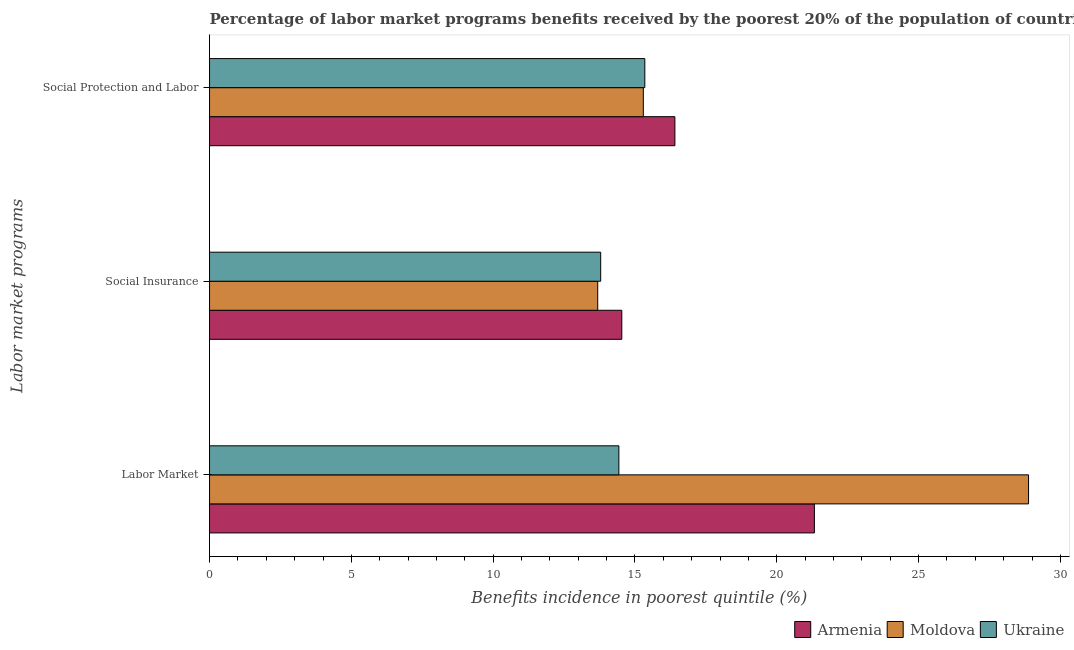Are the number of bars on each tick of the Y-axis equal?
Your answer should be very brief. Yes. How many bars are there on the 2nd tick from the top?
Provide a short and direct response. 3. How many bars are there on the 1st tick from the bottom?
Ensure brevity in your answer.  3. What is the label of the 2nd group of bars from the top?
Make the answer very short. Social Insurance. What is the percentage of benefits received due to labor market programs in Moldova?
Your answer should be very brief. 28.88. Across all countries, what is the maximum percentage of benefits received due to labor market programs?
Give a very brief answer. 28.88. Across all countries, what is the minimum percentage of benefits received due to labor market programs?
Your answer should be very brief. 14.43. In which country was the percentage of benefits received due to social insurance programs maximum?
Ensure brevity in your answer.  Armenia. In which country was the percentage of benefits received due to social protection programs minimum?
Provide a succinct answer. Moldova. What is the total percentage of benefits received due to labor market programs in the graph?
Your answer should be very brief. 64.63. What is the difference between the percentage of benefits received due to labor market programs in Moldova and that in Ukraine?
Offer a very short reply. 14.44. What is the difference between the percentage of benefits received due to labor market programs in Armenia and the percentage of benefits received due to social insurance programs in Moldova?
Give a very brief answer. 7.64. What is the average percentage of benefits received due to labor market programs per country?
Keep it short and to the point. 21.54. What is the difference between the percentage of benefits received due to labor market programs and percentage of benefits received due to social insurance programs in Ukraine?
Your response must be concise. 0.64. In how many countries, is the percentage of benefits received due to social protection programs greater than 15 %?
Give a very brief answer. 3. What is the ratio of the percentage of benefits received due to social insurance programs in Ukraine to that in Moldova?
Your response must be concise. 1.01. Is the percentage of benefits received due to social protection programs in Ukraine less than that in Moldova?
Offer a terse response. No. Is the difference between the percentage of benefits received due to social protection programs in Ukraine and Armenia greater than the difference between the percentage of benefits received due to social insurance programs in Ukraine and Armenia?
Offer a terse response. No. What is the difference between the highest and the second highest percentage of benefits received due to labor market programs?
Offer a very short reply. 7.55. What is the difference between the highest and the lowest percentage of benefits received due to social protection programs?
Offer a very short reply. 1.11. What does the 1st bar from the top in Labor Market represents?
Provide a short and direct response. Ukraine. What does the 3rd bar from the bottom in Social Protection and Labor represents?
Ensure brevity in your answer.  Ukraine. Is it the case that in every country, the sum of the percentage of benefits received due to labor market programs and percentage of benefits received due to social insurance programs is greater than the percentage of benefits received due to social protection programs?
Provide a short and direct response. Yes. How many bars are there?
Your answer should be compact. 9. Are all the bars in the graph horizontal?
Ensure brevity in your answer.  Yes. How many countries are there in the graph?
Make the answer very short. 3. What is the difference between two consecutive major ticks on the X-axis?
Your answer should be very brief. 5. Are the values on the major ticks of X-axis written in scientific E-notation?
Offer a very short reply. No. Does the graph contain any zero values?
Keep it short and to the point. No. Where does the legend appear in the graph?
Give a very brief answer. Bottom right. What is the title of the graph?
Provide a succinct answer. Percentage of labor market programs benefits received by the poorest 20% of the population of countries. Does "Serbia" appear as one of the legend labels in the graph?
Make the answer very short. No. What is the label or title of the X-axis?
Your answer should be very brief. Benefits incidence in poorest quintile (%). What is the label or title of the Y-axis?
Give a very brief answer. Labor market programs. What is the Benefits incidence in poorest quintile (%) in Armenia in Labor Market?
Your response must be concise. 21.33. What is the Benefits incidence in poorest quintile (%) in Moldova in Labor Market?
Provide a succinct answer. 28.88. What is the Benefits incidence in poorest quintile (%) of Ukraine in Labor Market?
Make the answer very short. 14.43. What is the Benefits incidence in poorest quintile (%) in Armenia in Social Insurance?
Your response must be concise. 14.54. What is the Benefits incidence in poorest quintile (%) of Moldova in Social Insurance?
Your answer should be very brief. 13.69. What is the Benefits incidence in poorest quintile (%) of Ukraine in Social Insurance?
Offer a terse response. 13.79. What is the Benefits incidence in poorest quintile (%) in Armenia in Social Protection and Labor?
Keep it short and to the point. 16.41. What is the Benefits incidence in poorest quintile (%) in Moldova in Social Protection and Labor?
Make the answer very short. 15.29. What is the Benefits incidence in poorest quintile (%) of Ukraine in Social Protection and Labor?
Your answer should be very brief. 15.35. Across all Labor market programs, what is the maximum Benefits incidence in poorest quintile (%) in Armenia?
Make the answer very short. 21.33. Across all Labor market programs, what is the maximum Benefits incidence in poorest quintile (%) of Moldova?
Offer a very short reply. 28.88. Across all Labor market programs, what is the maximum Benefits incidence in poorest quintile (%) in Ukraine?
Your answer should be very brief. 15.35. Across all Labor market programs, what is the minimum Benefits incidence in poorest quintile (%) of Armenia?
Your response must be concise. 14.54. Across all Labor market programs, what is the minimum Benefits incidence in poorest quintile (%) in Moldova?
Provide a short and direct response. 13.69. Across all Labor market programs, what is the minimum Benefits incidence in poorest quintile (%) in Ukraine?
Offer a terse response. 13.79. What is the total Benefits incidence in poorest quintile (%) of Armenia in the graph?
Your response must be concise. 52.27. What is the total Benefits incidence in poorest quintile (%) of Moldova in the graph?
Your response must be concise. 57.86. What is the total Benefits incidence in poorest quintile (%) in Ukraine in the graph?
Provide a short and direct response. 43.57. What is the difference between the Benefits incidence in poorest quintile (%) in Armenia in Labor Market and that in Social Insurance?
Ensure brevity in your answer.  6.79. What is the difference between the Benefits incidence in poorest quintile (%) of Moldova in Labor Market and that in Social Insurance?
Your response must be concise. 15.19. What is the difference between the Benefits incidence in poorest quintile (%) of Ukraine in Labor Market and that in Social Insurance?
Offer a very short reply. 0.64. What is the difference between the Benefits incidence in poorest quintile (%) in Armenia in Labor Market and that in Social Protection and Labor?
Ensure brevity in your answer.  4.92. What is the difference between the Benefits incidence in poorest quintile (%) of Moldova in Labor Market and that in Social Protection and Labor?
Your answer should be very brief. 13.58. What is the difference between the Benefits incidence in poorest quintile (%) of Ukraine in Labor Market and that in Social Protection and Labor?
Your answer should be compact. -0.91. What is the difference between the Benefits incidence in poorest quintile (%) of Armenia in Social Insurance and that in Social Protection and Labor?
Offer a terse response. -1.87. What is the difference between the Benefits incidence in poorest quintile (%) of Moldova in Social Insurance and that in Social Protection and Labor?
Your answer should be very brief. -1.61. What is the difference between the Benefits incidence in poorest quintile (%) in Ukraine in Social Insurance and that in Social Protection and Labor?
Provide a short and direct response. -1.56. What is the difference between the Benefits incidence in poorest quintile (%) in Armenia in Labor Market and the Benefits incidence in poorest quintile (%) in Moldova in Social Insurance?
Provide a short and direct response. 7.64. What is the difference between the Benefits incidence in poorest quintile (%) of Armenia in Labor Market and the Benefits incidence in poorest quintile (%) of Ukraine in Social Insurance?
Provide a short and direct response. 7.53. What is the difference between the Benefits incidence in poorest quintile (%) of Moldova in Labor Market and the Benefits incidence in poorest quintile (%) of Ukraine in Social Insurance?
Your answer should be compact. 15.09. What is the difference between the Benefits incidence in poorest quintile (%) of Armenia in Labor Market and the Benefits incidence in poorest quintile (%) of Moldova in Social Protection and Labor?
Your response must be concise. 6.03. What is the difference between the Benefits incidence in poorest quintile (%) of Armenia in Labor Market and the Benefits incidence in poorest quintile (%) of Ukraine in Social Protection and Labor?
Your answer should be very brief. 5.98. What is the difference between the Benefits incidence in poorest quintile (%) of Moldova in Labor Market and the Benefits incidence in poorest quintile (%) of Ukraine in Social Protection and Labor?
Offer a very short reply. 13.53. What is the difference between the Benefits incidence in poorest quintile (%) of Armenia in Social Insurance and the Benefits incidence in poorest quintile (%) of Moldova in Social Protection and Labor?
Offer a terse response. -0.76. What is the difference between the Benefits incidence in poorest quintile (%) in Armenia in Social Insurance and the Benefits incidence in poorest quintile (%) in Ukraine in Social Protection and Labor?
Keep it short and to the point. -0.81. What is the difference between the Benefits incidence in poorest quintile (%) of Moldova in Social Insurance and the Benefits incidence in poorest quintile (%) of Ukraine in Social Protection and Labor?
Offer a terse response. -1.66. What is the average Benefits incidence in poorest quintile (%) of Armenia per Labor market programs?
Keep it short and to the point. 17.42. What is the average Benefits incidence in poorest quintile (%) in Moldova per Labor market programs?
Offer a very short reply. 19.29. What is the average Benefits incidence in poorest quintile (%) in Ukraine per Labor market programs?
Your response must be concise. 14.52. What is the difference between the Benefits incidence in poorest quintile (%) of Armenia and Benefits incidence in poorest quintile (%) of Moldova in Labor Market?
Your answer should be compact. -7.55. What is the difference between the Benefits incidence in poorest quintile (%) in Armenia and Benefits incidence in poorest quintile (%) in Ukraine in Labor Market?
Your answer should be very brief. 6.89. What is the difference between the Benefits incidence in poorest quintile (%) of Moldova and Benefits incidence in poorest quintile (%) of Ukraine in Labor Market?
Provide a short and direct response. 14.44. What is the difference between the Benefits incidence in poorest quintile (%) in Armenia and Benefits incidence in poorest quintile (%) in Moldova in Social Insurance?
Your answer should be compact. 0.85. What is the difference between the Benefits incidence in poorest quintile (%) in Armenia and Benefits incidence in poorest quintile (%) in Ukraine in Social Insurance?
Give a very brief answer. 0.74. What is the difference between the Benefits incidence in poorest quintile (%) of Moldova and Benefits incidence in poorest quintile (%) of Ukraine in Social Insurance?
Make the answer very short. -0.1. What is the difference between the Benefits incidence in poorest quintile (%) of Armenia and Benefits incidence in poorest quintile (%) of Moldova in Social Protection and Labor?
Your answer should be very brief. 1.11. What is the difference between the Benefits incidence in poorest quintile (%) in Armenia and Benefits incidence in poorest quintile (%) in Ukraine in Social Protection and Labor?
Keep it short and to the point. 1.06. What is the difference between the Benefits incidence in poorest quintile (%) in Moldova and Benefits incidence in poorest quintile (%) in Ukraine in Social Protection and Labor?
Give a very brief answer. -0.05. What is the ratio of the Benefits incidence in poorest quintile (%) in Armenia in Labor Market to that in Social Insurance?
Provide a succinct answer. 1.47. What is the ratio of the Benefits incidence in poorest quintile (%) in Moldova in Labor Market to that in Social Insurance?
Give a very brief answer. 2.11. What is the ratio of the Benefits incidence in poorest quintile (%) of Ukraine in Labor Market to that in Social Insurance?
Provide a short and direct response. 1.05. What is the ratio of the Benefits incidence in poorest quintile (%) in Armenia in Labor Market to that in Social Protection and Labor?
Provide a short and direct response. 1.3. What is the ratio of the Benefits incidence in poorest quintile (%) of Moldova in Labor Market to that in Social Protection and Labor?
Ensure brevity in your answer.  1.89. What is the ratio of the Benefits incidence in poorest quintile (%) in Ukraine in Labor Market to that in Social Protection and Labor?
Offer a terse response. 0.94. What is the ratio of the Benefits incidence in poorest quintile (%) of Armenia in Social Insurance to that in Social Protection and Labor?
Give a very brief answer. 0.89. What is the ratio of the Benefits incidence in poorest quintile (%) in Moldova in Social Insurance to that in Social Protection and Labor?
Your answer should be compact. 0.89. What is the ratio of the Benefits incidence in poorest quintile (%) of Ukraine in Social Insurance to that in Social Protection and Labor?
Your answer should be very brief. 0.9. What is the difference between the highest and the second highest Benefits incidence in poorest quintile (%) of Armenia?
Make the answer very short. 4.92. What is the difference between the highest and the second highest Benefits incidence in poorest quintile (%) in Moldova?
Your answer should be very brief. 13.58. What is the difference between the highest and the second highest Benefits incidence in poorest quintile (%) of Ukraine?
Offer a very short reply. 0.91. What is the difference between the highest and the lowest Benefits incidence in poorest quintile (%) in Armenia?
Keep it short and to the point. 6.79. What is the difference between the highest and the lowest Benefits incidence in poorest quintile (%) of Moldova?
Ensure brevity in your answer.  15.19. What is the difference between the highest and the lowest Benefits incidence in poorest quintile (%) of Ukraine?
Ensure brevity in your answer.  1.56. 